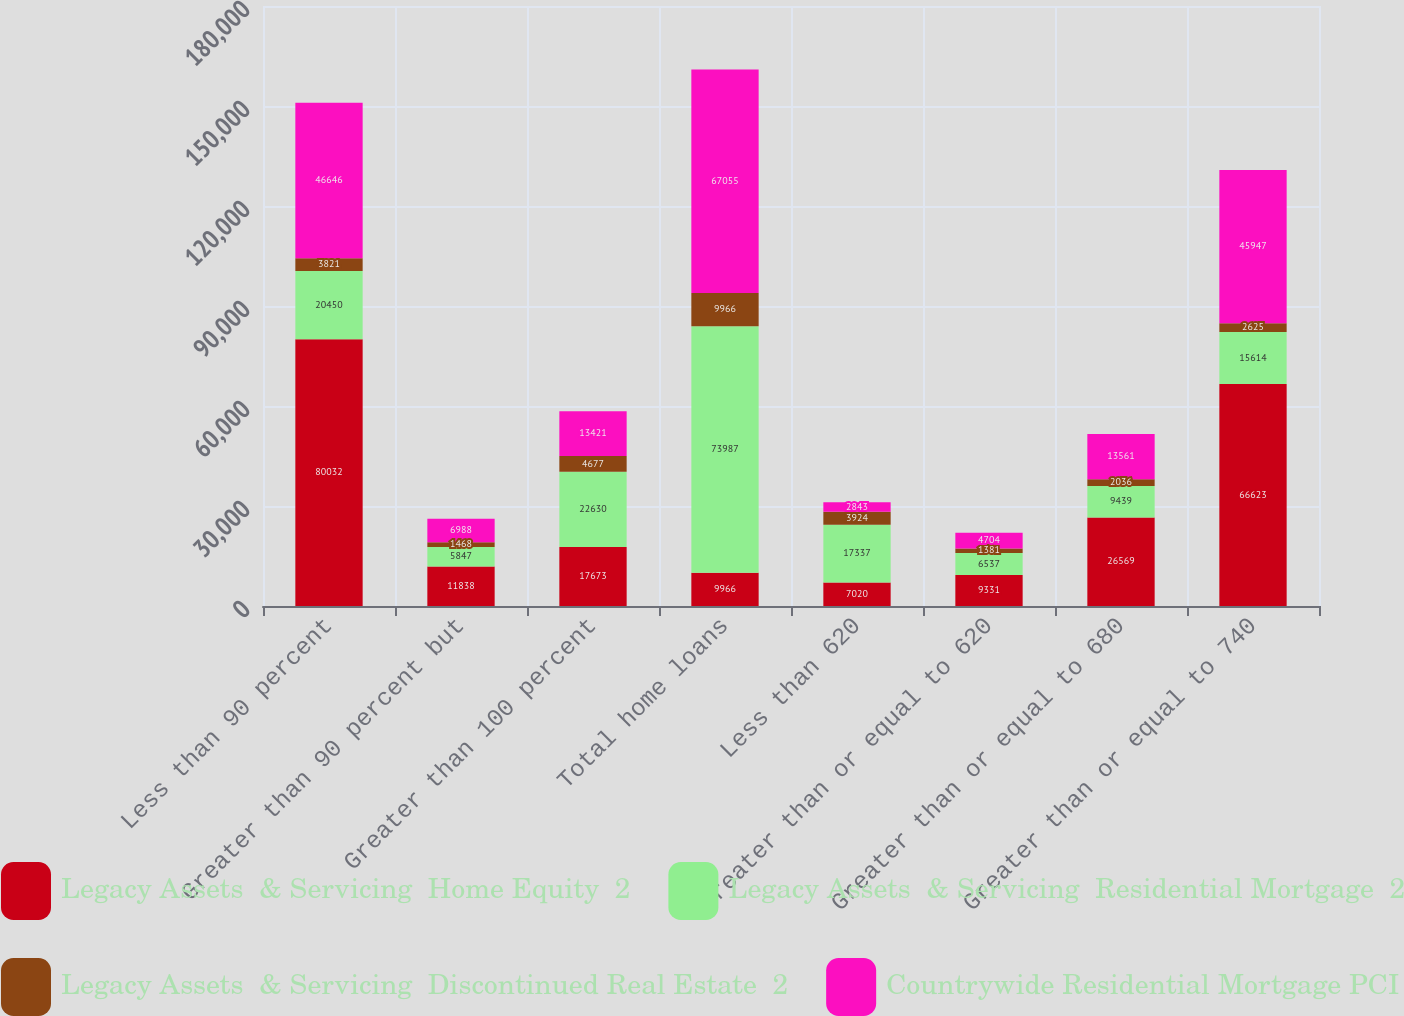Convert chart to OTSL. <chart><loc_0><loc_0><loc_500><loc_500><stacked_bar_chart><ecel><fcel>Less than 90 percent<fcel>Greater than 90 percent but<fcel>Greater than 100 percent<fcel>Total home loans<fcel>Less than 620<fcel>Greater than or equal to 620<fcel>Greater than or equal to 680<fcel>Greater than or equal to 740<nl><fcel>Legacy Assets  & Servicing  Home Equity  2<fcel>80032<fcel>11838<fcel>17673<fcel>9966<fcel>7020<fcel>9331<fcel>26569<fcel>66623<nl><fcel>Legacy Assets  & Servicing  Residential Mortgage  2<fcel>20450<fcel>5847<fcel>22630<fcel>73987<fcel>17337<fcel>6537<fcel>9439<fcel>15614<nl><fcel>Legacy Assets  & Servicing  Discontinued Real Estate  2<fcel>3821<fcel>1468<fcel>4677<fcel>9966<fcel>3924<fcel>1381<fcel>2036<fcel>2625<nl><fcel>Countrywide Residential Mortgage PCI<fcel>46646<fcel>6988<fcel>13421<fcel>67055<fcel>2843<fcel>4704<fcel>13561<fcel>45947<nl></chart> 